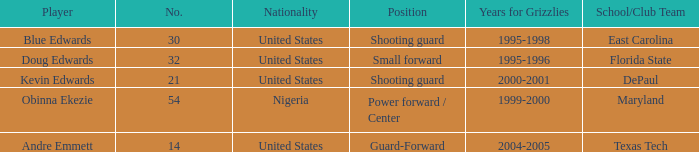When did player no. 32 appear for the grizzlies? 1995-1996. 